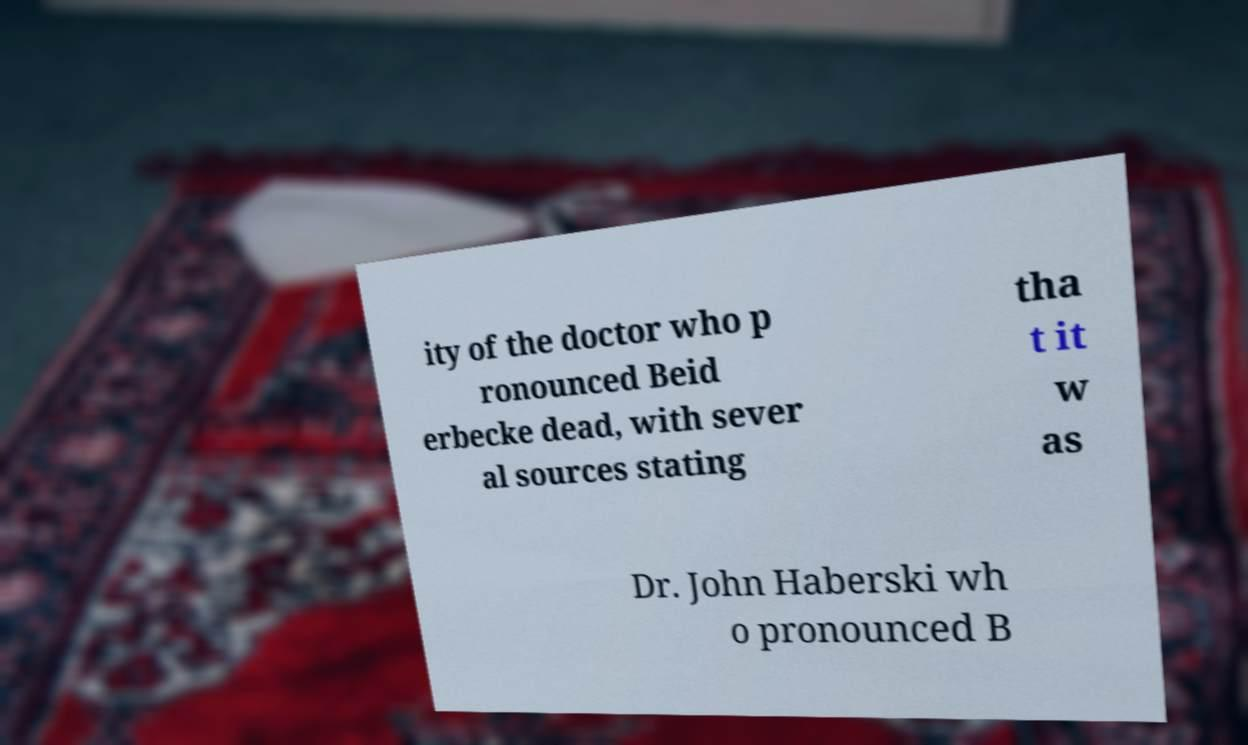What messages or text are displayed in this image? I need them in a readable, typed format. ity of the doctor who p ronounced Beid erbecke dead, with sever al sources stating tha t it w as Dr. John Haberski wh o pronounced B 